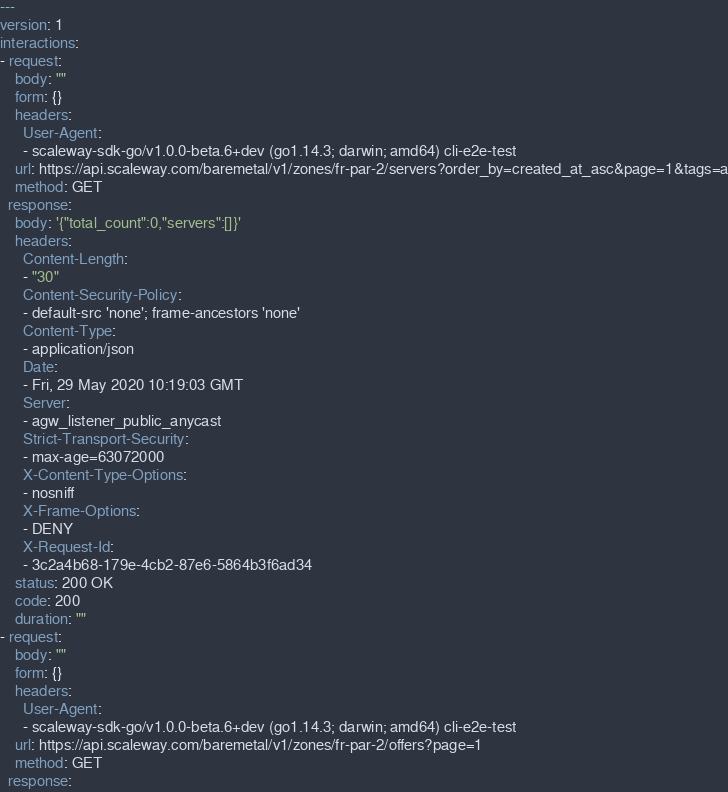<code> <loc_0><loc_0><loc_500><loc_500><_YAML_>---
version: 1
interactions:
- request:
    body: ""
    form: {}
    headers:
      User-Agent:
      - scaleway-sdk-go/v1.0.0-beta.6+dev (go1.14.3; darwin; amd64) cli-e2e-test
    url: https://api.scaleway.com/baremetal/v1/zones/fr-par-2/servers?order_by=created_at_asc&page=1&tags=a
    method: GET
  response:
    body: '{"total_count":0,"servers":[]}'
    headers:
      Content-Length:
      - "30"
      Content-Security-Policy:
      - default-src 'none'; frame-ancestors 'none'
      Content-Type:
      - application/json
      Date:
      - Fri, 29 May 2020 10:19:03 GMT
      Server:
      - agw_listener_public_anycast
      Strict-Transport-Security:
      - max-age=63072000
      X-Content-Type-Options:
      - nosniff
      X-Frame-Options:
      - DENY
      X-Request-Id:
      - 3c2a4b68-179e-4cb2-87e6-5864b3f6ad34
    status: 200 OK
    code: 200
    duration: ""
- request:
    body: ""
    form: {}
    headers:
      User-Agent:
      - scaleway-sdk-go/v1.0.0-beta.6+dev (go1.14.3; darwin; amd64) cli-e2e-test
    url: https://api.scaleway.com/baremetal/v1/zones/fr-par-2/offers?page=1
    method: GET
  response:</code> 